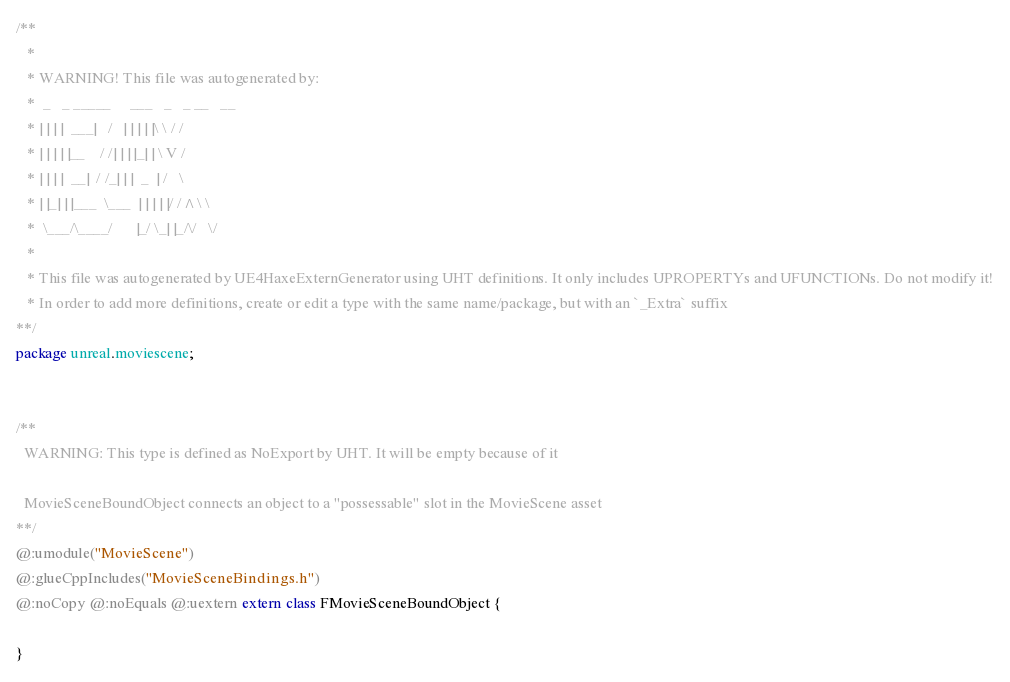Convert code to text. <code><loc_0><loc_0><loc_500><loc_500><_Haxe_>/**
   * 
   * WARNING! This file was autogenerated by: 
   *  _   _ _____     ___   _   _ __   __ 
   * | | | |  ___|   /   | | | | |\ \ / / 
   * | | | | |__    / /| | | |_| | \ V /  
   * | | | |  __|  / /_| | |  _  | /   \  
   * | |_| | |___  \___  | | | | |/ /^\ \ 
   *  \___/\____/      |_/ \_| |_/\/   \/ 
   * 
   * This file was autogenerated by UE4HaxeExternGenerator using UHT definitions. It only includes UPROPERTYs and UFUNCTIONs. Do not modify it!
   * In order to add more definitions, create or edit a type with the same name/package, but with an `_Extra` suffix
**/
package unreal.moviescene;


/**
  WARNING: This type is defined as NoExport by UHT. It will be empty because of it
  
  MovieSceneBoundObject connects an object to a "possessable" slot in the MovieScene asset
**/
@:umodule("MovieScene")
@:glueCppIncludes("MovieSceneBindings.h")
@:noCopy @:noEquals @:uextern extern class FMovieSceneBoundObject {
  
}
</code> 